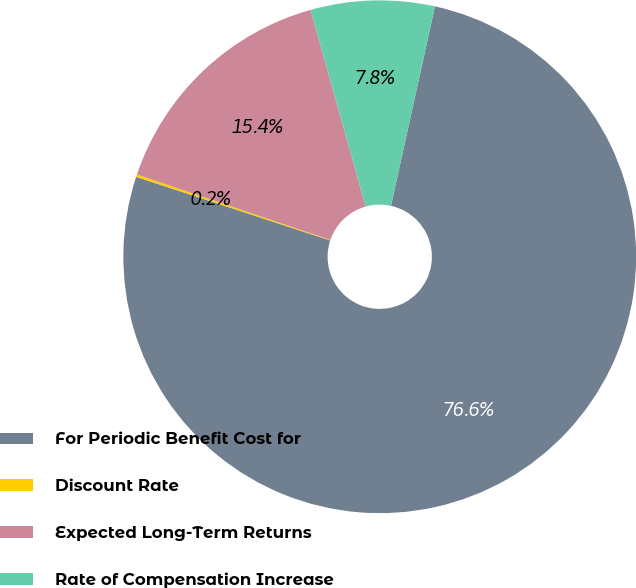Convert chart. <chart><loc_0><loc_0><loc_500><loc_500><pie_chart><fcel>For Periodic Benefit Cost for<fcel>Discount Rate<fcel>Expected Long-Term Returns<fcel>Rate of Compensation Increase<nl><fcel>76.59%<fcel>0.16%<fcel>15.45%<fcel>7.8%<nl></chart> 